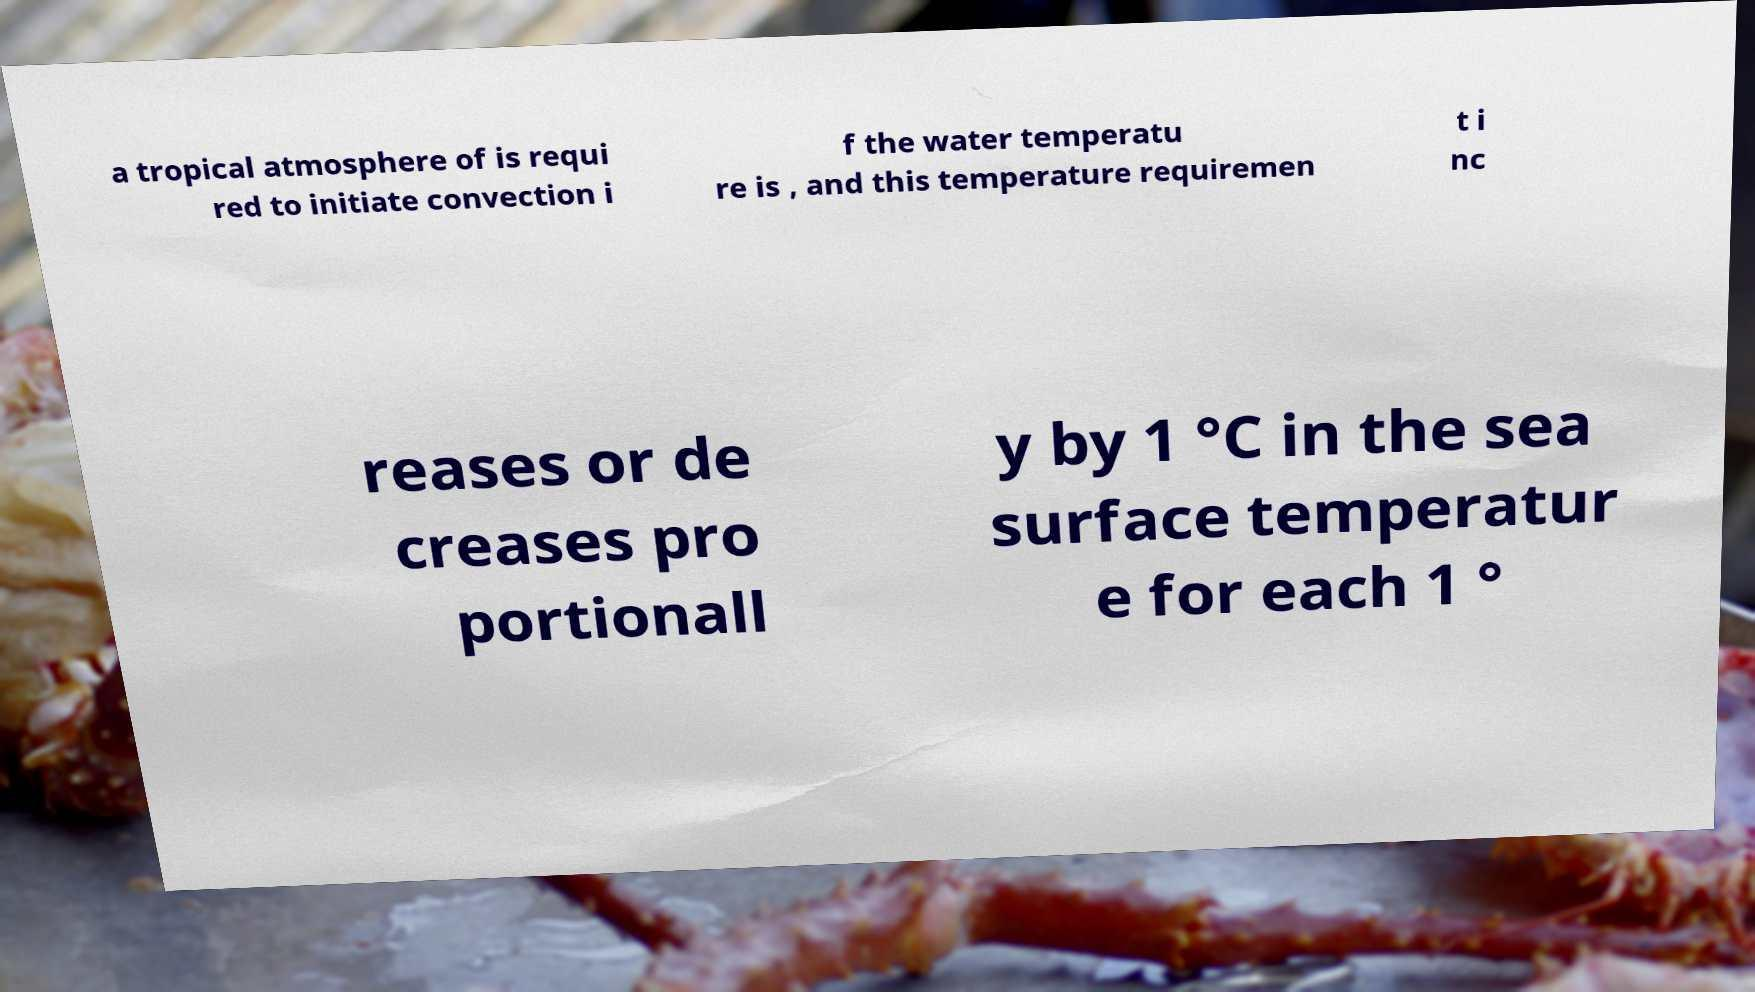For documentation purposes, I need the text within this image transcribed. Could you provide that? a tropical atmosphere of is requi red to initiate convection i f the water temperatu re is , and this temperature requiremen t i nc reases or de creases pro portionall y by 1 °C in the sea surface temperatur e for each 1 ° 